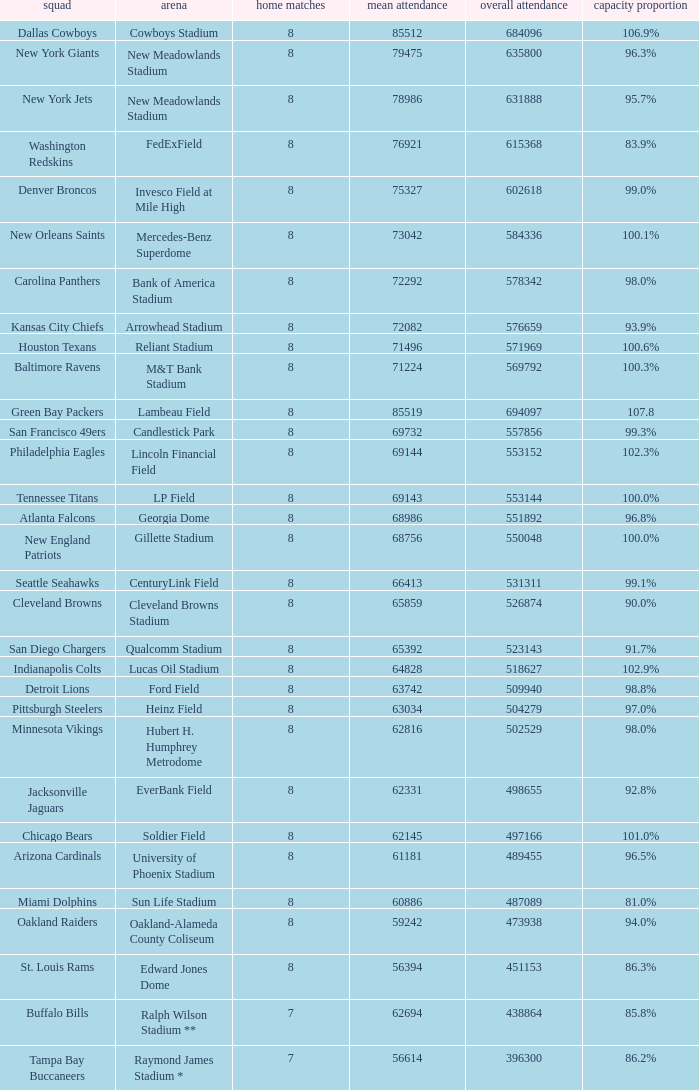What is the capacity percentage when the total attendance is 509940? 98.8%. 